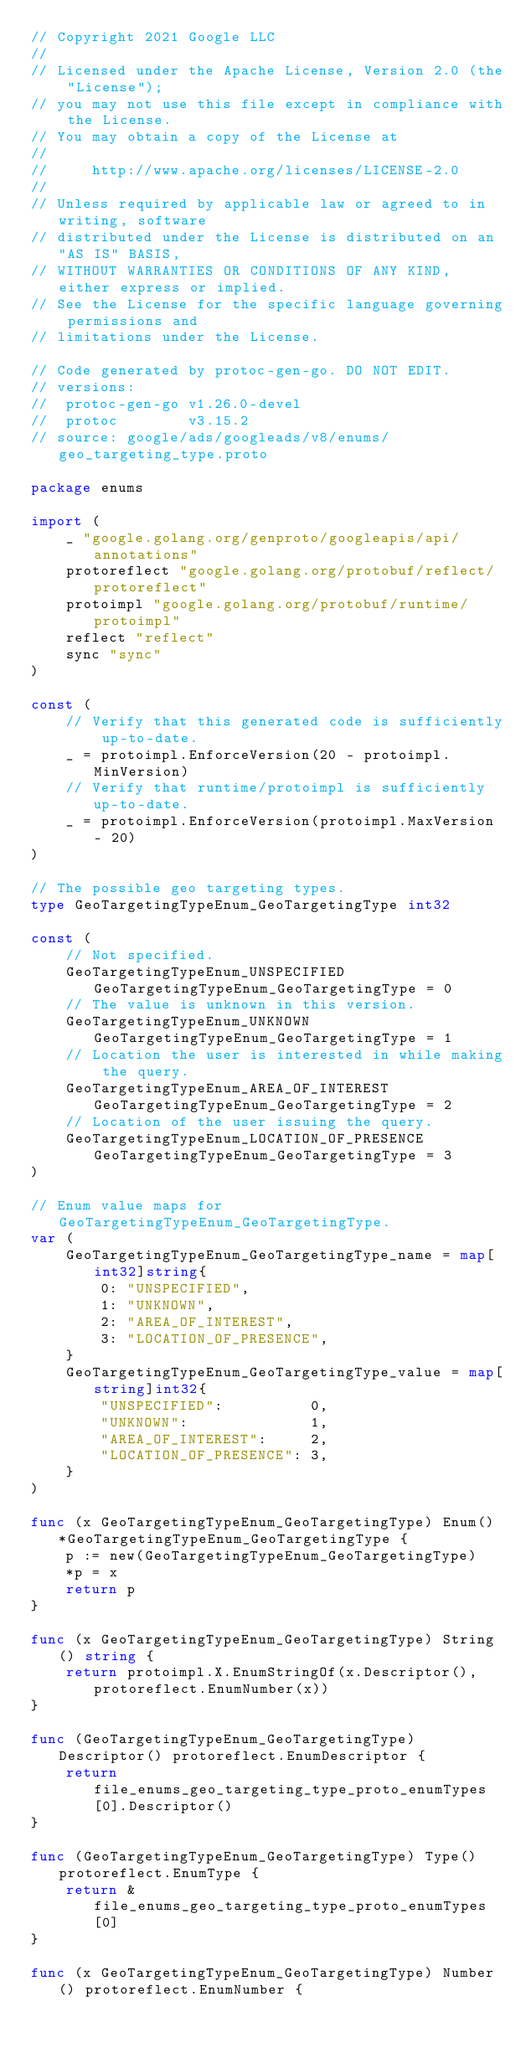Convert code to text. <code><loc_0><loc_0><loc_500><loc_500><_Go_>// Copyright 2021 Google LLC
//
// Licensed under the Apache License, Version 2.0 (the "License");
// you may not use this file except in compliance with the License.
// You may obtain a copy of the License at
//
//     http://www.apache.org/licenses/LICENSE-2.0
//
// Unless required by applicable law or agreed to in writing, software
// distributed under the License is distributed on an "AS IS" BASIS,
// WITHOUT WARRANTIES OR CONDITIONS OF ANY KIND, either express or implied.
// See the License for the specific language governing permissions and
// limitations under the License.

// Code generated by protoc-gen-go. DO NOT EDIT.
// versions:
// 	protoc-gen-go v1.26.0-devel
// 	protoc        v3.15.2
// source: google/ads/googleads/v8/enums/geo_targeting_type.proto

package enums

import (
	_ "google.golang.org/genproto/googleapis/api/annotations"
	protoreflect "google.golang.org/protobuf/reflect/protoreflect"
	protoimpl "google.golang.org/protobuf/runtime/protoimpl"
	reflect "reflect"
	sync "sync"
)

const (
	// Verify that this generated code is sufficiently up-to-date.
	_ = protoimpl.EnforceVersion(20 - protoimpl.MinVersion)
	// Verify that runtime/protoimpl is sufficiently up-to-date.
	_ = protoimpl.EnforceVersion(protoimpl.MaxVersion - 20)
)

// The possible geo targeting types.
type GeoTargetingTypeEnum_GeoTargetingType int32

const (
	// Not specified.
	GeoTargetingTypeEnum_UNSPECIFIED GeoTargetingTypeEnum_GeoTargetingType = 0
	// The value is unknown in this version.
	GeoTargetingTypeEnum_UNKNOWN GeoTargetingTypeEnum_GeoTargetingType = 1
	// Location the user is interested in while making the query.
	GeoTargetingTypeEnum_AREA_OF_INTEREST GeoTargetingTypeEnum_GeoTargetingType = 2
	// Location of the user issuing the query.
	GeoTargetingTypeEnum_LOCATION_OF_PRESENCE GeoTargetingTypeEnum_GeoTargetingType = 3
)

// Enum value maps for GeoTargetingTypeEnum_GeoTargetingType.
var (
	GeoTargetingTypeEnum_GeoTargetingType_name = map[int32]string{
		0: "UNSPECIFIED",
		1: "UNKNOWN",
		2: "AREA_OF_INTEREST",
		3: "LOCATION_OF_PRESENCE",
	}
	GeoTargetingTypeEnum_GeoTargetingType_value = map[string]int32{
		"UNSPECIFIED":          0,
		"UNKNOWN":              1,
		"AREA_OF_INTEREST":     2,
		"LOCATION_OF_PRESENCE": 3,
	}
)

func (x GeoTargetingTypeEnum_GeoTargetingType) Enum() *GeoTargetingTypeEnum_GeoTargetingType {
	p := new(GeoTargetingTypeEnum_GeoTargetingType)
	*p = x
	return p
}

func (x GeoTargetingTypeEnum_GeoTargetingType) String() string {
	return protoimpl.X.EnumStringOf(x.Descriptor(), protoreflect.EnumNumber(x))
}

func (GeoTargetingTypeEnum_GeoTargetingType) Descriptor() protoreflect.EnumDescriptor {
	return file_enums_geo_targeting_type_proto_enumTypes[0].Descriptor()
}

func (GeoTargetingTypeEnum_GeoTargetingType) Type() protoreflect.EnumType {
	return &file_enums_geo_targeting_type_proto_enumTypes[0]
}

func (x GeoTargetingTypeEnum_GeoTargetingType) Number() protoreflect.EnumNumber {</code> 